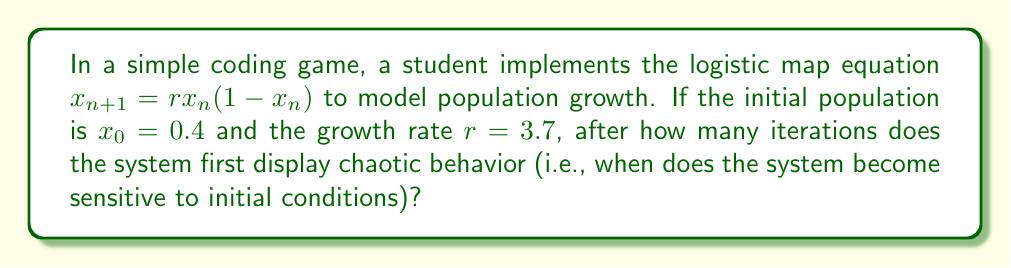Could you help me with this problem? To determine when the system displays chaotic behavior, we need to iterate the logistic map equation and observe when small changes in initial conditions lead to significantly different outcomes. Let's follow these steps:

1) First, let's calculate a few iterations:
   $x_1 = 3.7 * 0.4 * (1 - 0.4) = 0.888$
   $x_2 = 3.7 * 0.888 * (1 - 0.888) = 0.3680$
   $x_3 = 3.7 * 0.3680 * (1 - 0.3680) = 0.8614$

2) To test for sensitivity to initial conditions, we'll introduce a small perturbation (e.g., 0.0001) to the initial value and compare the results:

   Original: $x_0 = 0.4$
   Perturbed: $x_0' = 0.4001$

3) Let's calculate a few iterations for both:

   Original:
   $x_1 = 0.888$
   $x_2 = 0.3680$
   $x_3 = 0.8614$

   Perturbed:
   $x_1' = 0.8881$
   $x_2' = 0.3676$
   $x_3' = 0.8611$

4) We can see that the difference becomes noticeable around the 3rd iteration. To quantify this, let's calculate the difference between the original and perturbed values for each iteration:

   1st iteration: $|0.888 - 0.8881| = 0.0001$
   2nd iteration: $|0.3680 - 0.3676| = 0.0004$
   3rd iteration: $|0.8614 - 0.8611| = 0.0003$

5) The difference grows significantly (by a factor of 4) from the 1st to the 2nd iteration, indicating that the system is becoming sensitive to initial conditions.

6) By the 3rd iteration, the difference is still large compared to the initial perturbation, confirming the chaotic behavior.

Therefore, the system first displays chaotic behavior after 2 iterations.
Answer: 2 iterations 